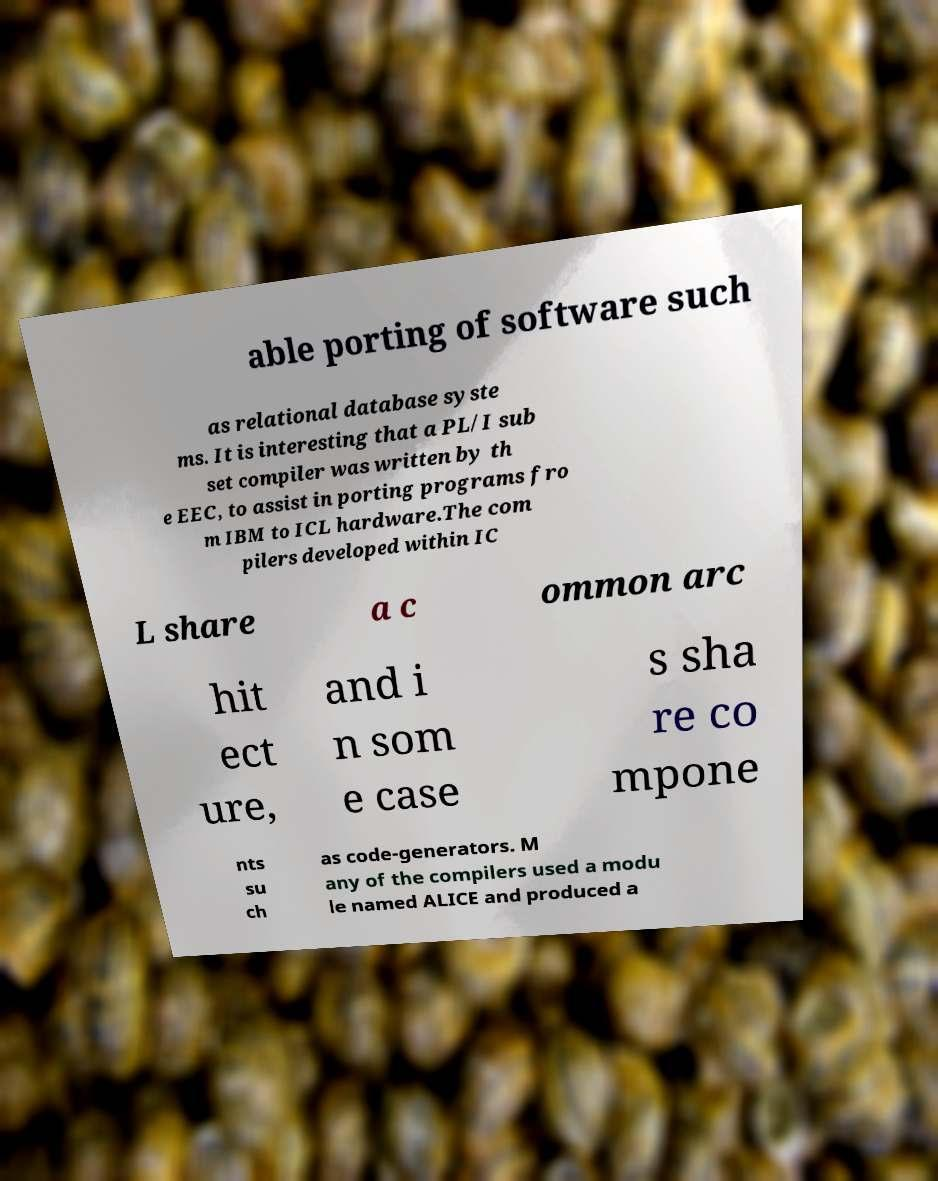What messages or text are displayed in this image? I need them in a readable, typed format. able porting of software such as relational database syste ms. It is interesting that a PL/I sub set compiler was written by th e EEC, to assist in porting programs fro m IBM to ICL hardware.The com pilers developed within IC L share a c ommon arc hit ect ure, and i n som e case s sha re co mpone nts su ch as code-generators. M any of the compilers used a modu le named ALICE and produced a 